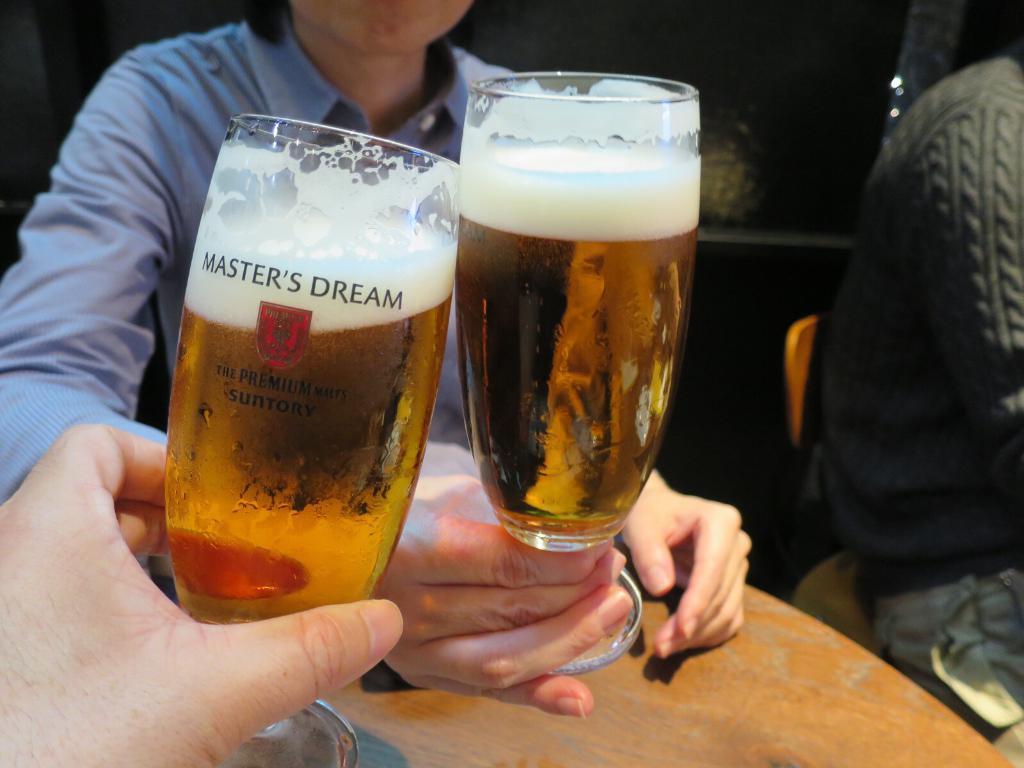In one or two sentences, can you explain what this image depicts? On the left of this picture we can see a person wearing a shirt, sitting and holding the glass of drink. In the bottom left corner we can see the hand of a person holding the glass of drink and we can see the text and a logo on the glass. In the foreground we can see the wooden table. On the right there is another person sitting on the chair. In the background we can see some objects. 